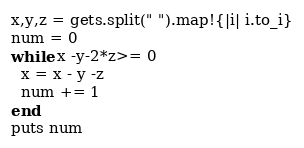Convert code to text. <code><loc_0><loc_0><loc_500><loc_500><_Ruby_>x,y,z = gets.split(" ").map!{|i| i.to_i}
num = 0
while x -y-2*z>= 0
  x = x - y -z
  num += 1
end
puts num
</code> 